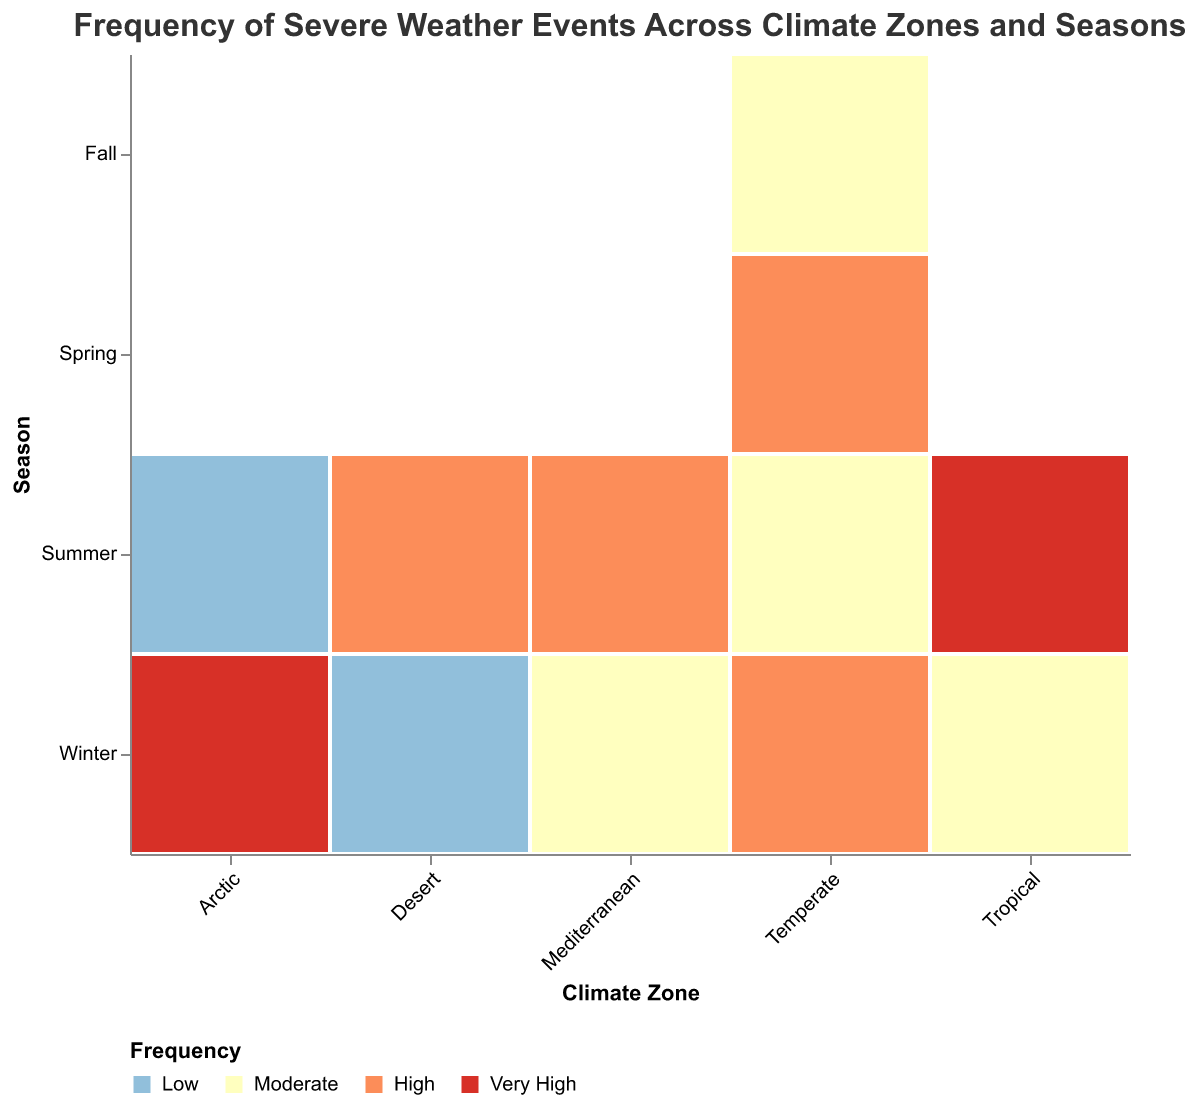Which climate zone experiences the highest frequency of hurricanes in summer? In the "Climate Zone" axis, find the "Tropical" zone, then look at the summer row and identify the frequency of hurricanes.
Answer: High In which season does the Temperate climate zone experience the highest frequency of blizzards? In the "Climate Zone" axis, find the "Temperate" zone, then look at the seasons and check the frequency of blizzards. Winter has the highest frequency.
Answer: Winter Compare the frequency of thunderstorms in the Tropical climate zone between summer and winter. In the "Climate Zone" axis, find the "Tropical" zone, then compare the frequency of thunderstorms in summer ("Very High") and winter ("Moderate").
Answer: Summer's frequency is higher Which severe weather event occurs with "Very High" frequency in the Arctic climate zone? In the "Climate Zone" axis, find the "Arctic" zone, then look for any severe weather event marked with the color representing "Very High" frequency.
Answer: Blizzard What is the frequency of tornadoes in Temperate zones during spring compared to summer? In the "Climate Zone" axis, find the "Temperate" zone, then compare the frequency of tornadoes in spring ("High") and summer ("Moderate").
Answer: Spring's frequency is higher What kind of severe weather event has "Moderate" frequency in the Mediterranean climate zone during winter? In the "Climate Zone" axis, find the "Mediterranean" zone, look at winter, and identify the severe weather event marked as "Moderate."
Answer: Flash Flood How does the frequency of severe weather events in the Desert zone vary between summer and winter? In the "Climate Zone" axis, find the "Desert" zone, then compare the frequency of Dust Storms in summer ("High") to Flash Floods in winter ("Low").
Answer: Summer's frequency is higher Which climate zones experience severe weather events with "Very High" frequency during winter? Check the "Climate Zone" axis for any zones that have their "Winter" rows colored in the shade representing "Very High" frequency. "Arctic" zone has blizzards with "Very High" frequency.
Answer: Arctic In which season does the Tropical climate zone have a higher frequency of hurricanes? In the "Climate Zone" axis, find the "Tropical" zone, then compare the frequency of hurricanes between summer ("High") and winter ("Low").
Answer: Summer 